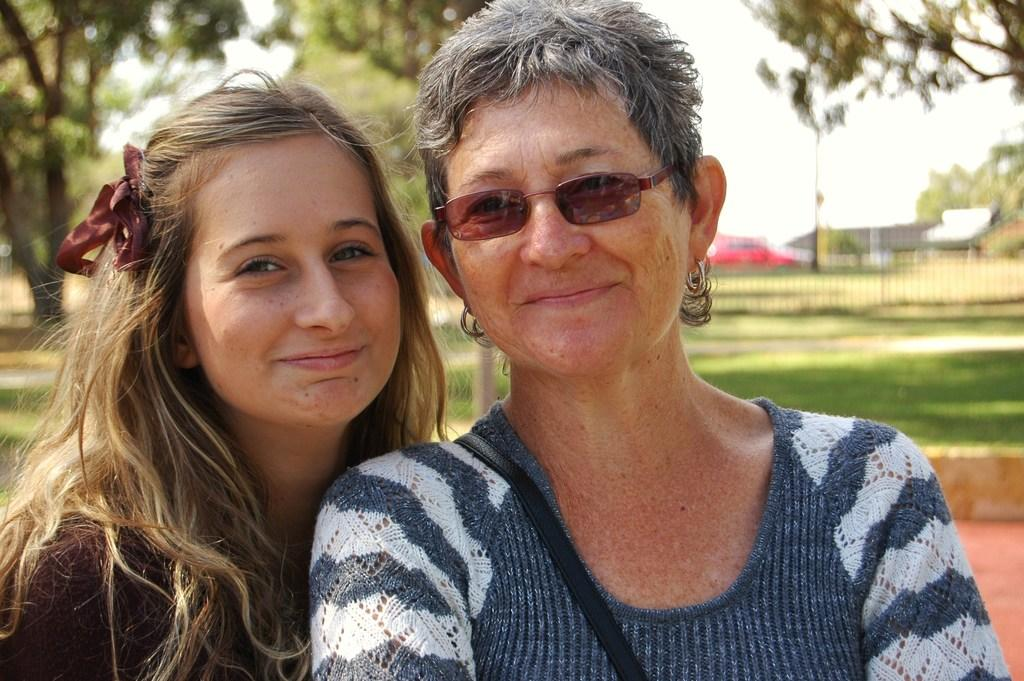Who or what can be seen in the front of the image? There are persons in the front of the image. What is the facial expression of the persons in the image? The persons are smiling. What type of vegetation is visible in the background of the image? There are trees in the background of the image. What is the ground made of in the image? There is grass on the ground in the image. What type of vehicle can be seen in the background of the image? There is a red car in the background of the image. What type of apple is being used to grab the attention of the persons in the image? There is no apple present in the image, and therefore no such activity can be observed. What type of chain is being used to connect the persons in the image? There is no chain present in the image, and the persons are not connected to each other. 